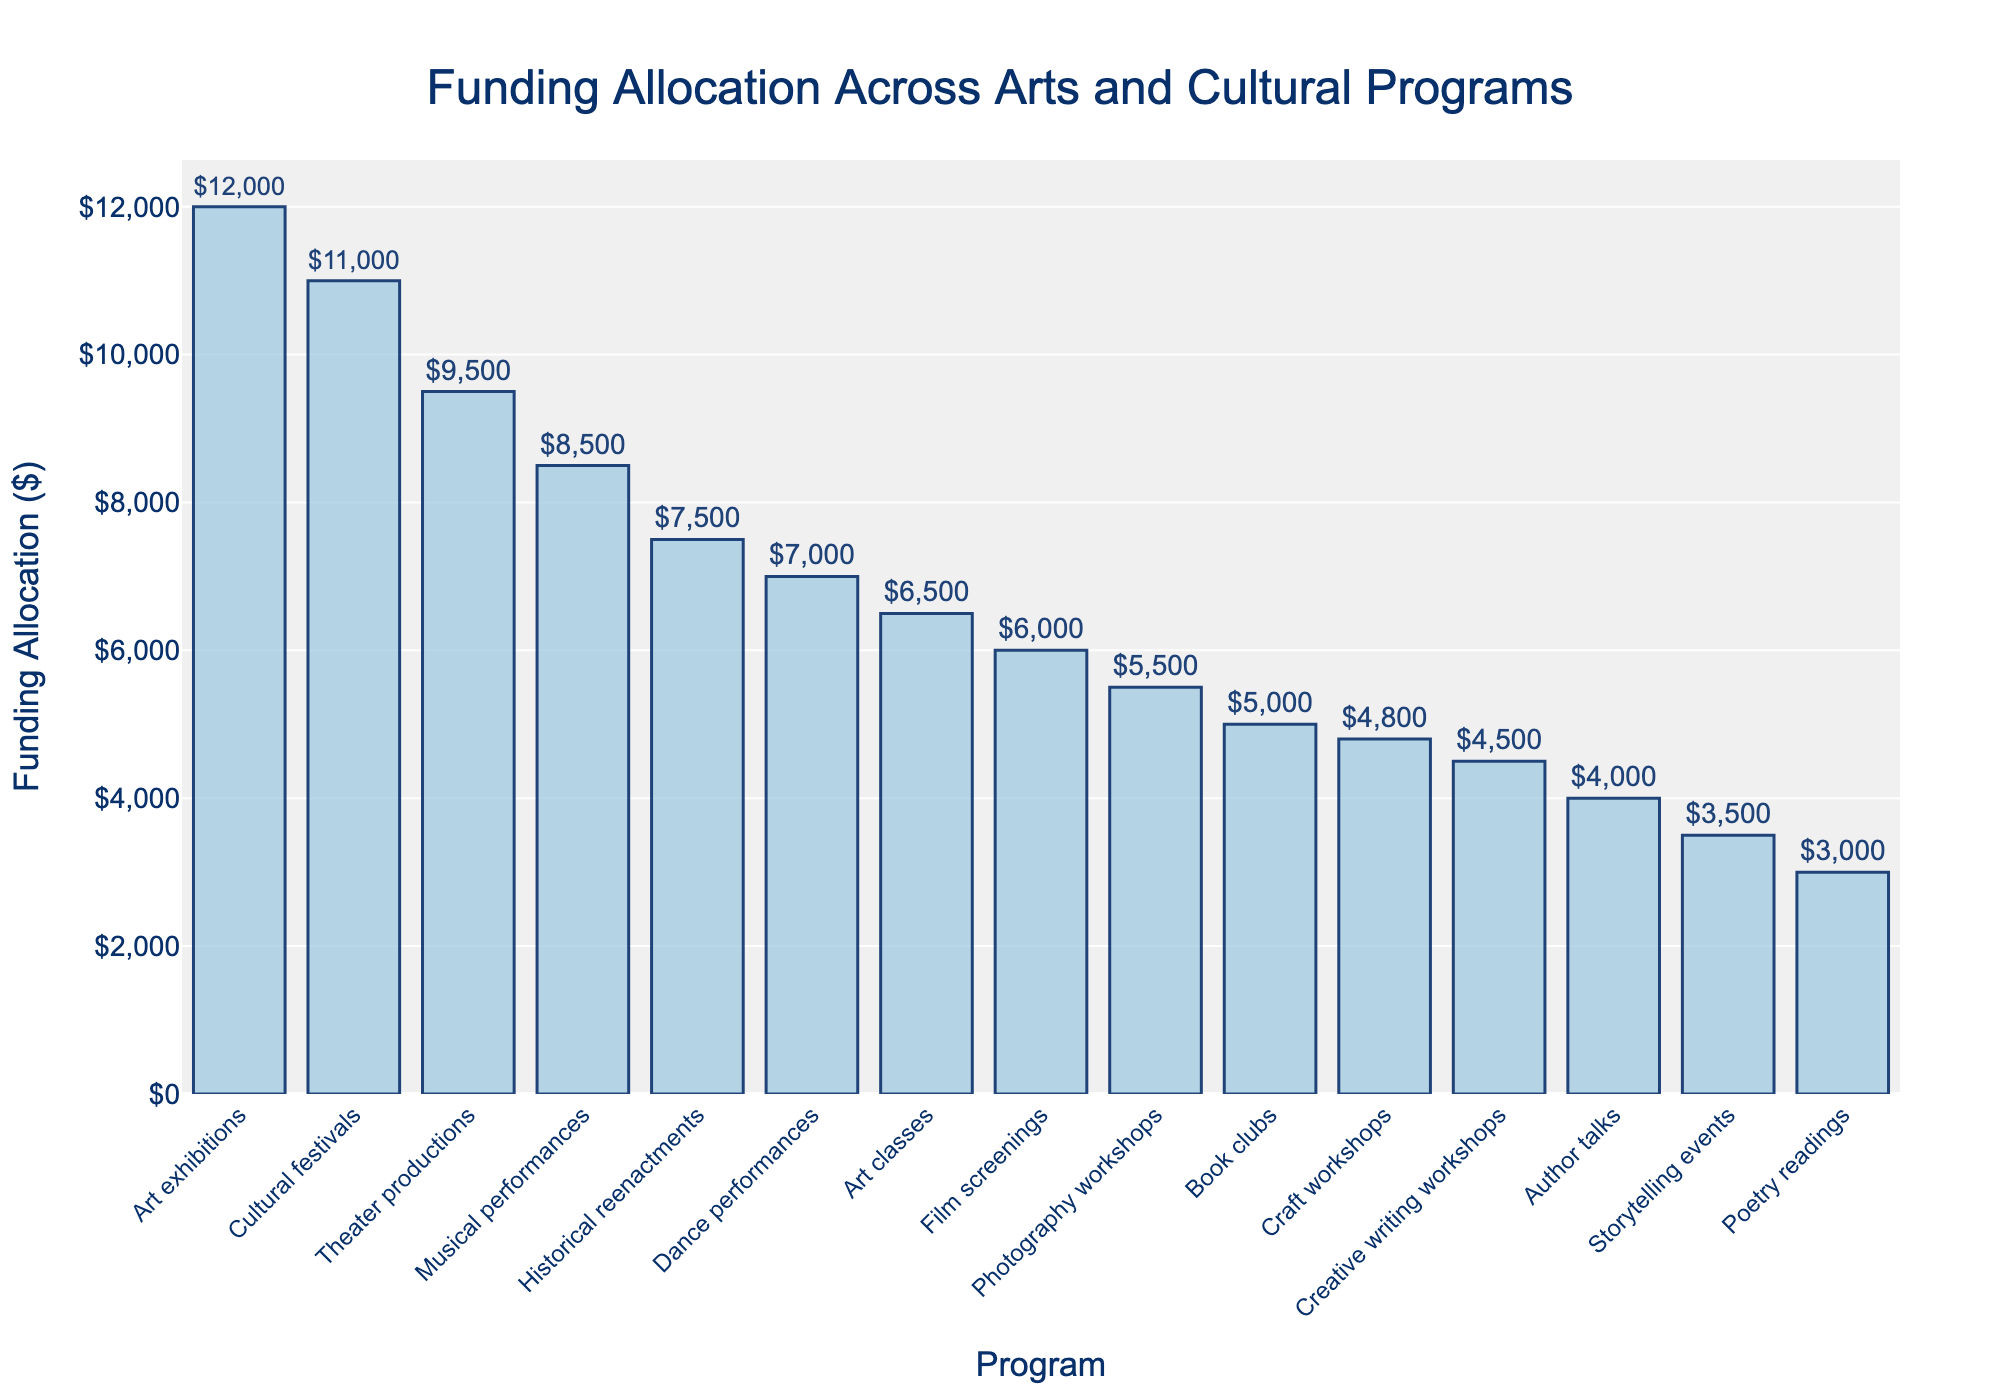Which program received the highest funding allocation? The bar chart shows the funding in descending order, and the longest bar indicates the highest allocation. The Art exhibitions bar is the longest.
Answer: Art exhibitions Which program received the lowest funding allocation? The shortest bar on the chart indicates the lowest allocation. The Poetry readings bar is the shortest.
Answer: Poetry readings How much more funding did Art exhibitions receive compared to Book clubs? From the chart, Art exhibitions received $12,000 and Book clubs received $5,000. The difference is $12,000 - $5,000.
Answer: $7,000 Which three programs received the highest funding allocations? The three longest bars on the chart represent the programs with the highest allocations. They are Art exhibitions, Cultural festivals, and Theater productions in order of longest bars.
Answer: Art exhibitions, Cultural festivals, Theater productions What is the total funding allocated to Musical performances and Dance performances together? From the chart, Musical performances received $8,500 and Dance performances received $7,000. The sum is $8,500 + $7,000.
Answer: $15,500 What is the average funding allocated to the top four programs? Sum the funding for the top four programs and divide by 4. Top four programs' funding: Art exhibitions ($12,000), Cultural festivals ($11,000), Theater productions ($9,500), and Musical performances ($8,500). The sum is $41,000, and the average is $41,000 / 4.
Answer: $10,250 Which program has a funding allocation closest to $5,000? By visual inspection of the bar lengths labeled near $5,000, both Book clubs ($5000) and Photography workshops ($5500) are close but Book clubs is the exact amount.
Answer: Book clubs Compare the total funding of Creative writing workshops and Author talks. Which one has higher funding and by how much? Creative writing workshops received $4,500, and Author talks received $4,000. The difference is $4,500 - $4,000.
Answer: Creative writing workshops, $500 Is the funding allocation for Historical reenactments greater or less than Film screenings? Historical reenactments received $7,500 and Film screenings received $6,000. Historical reenactments' allocation is greater.
Answer: Greater How much more funding does Historical reenactments have compared to the lowest funded program? Historical reenactments received $7,500 and Poetry readings received $3,000. The difference is $7,500 - $3,000.
Answer: $4,500 